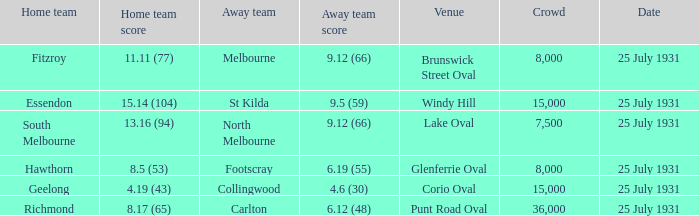When the home team was fitzroy, what did the away team score? 9.12 (66). 